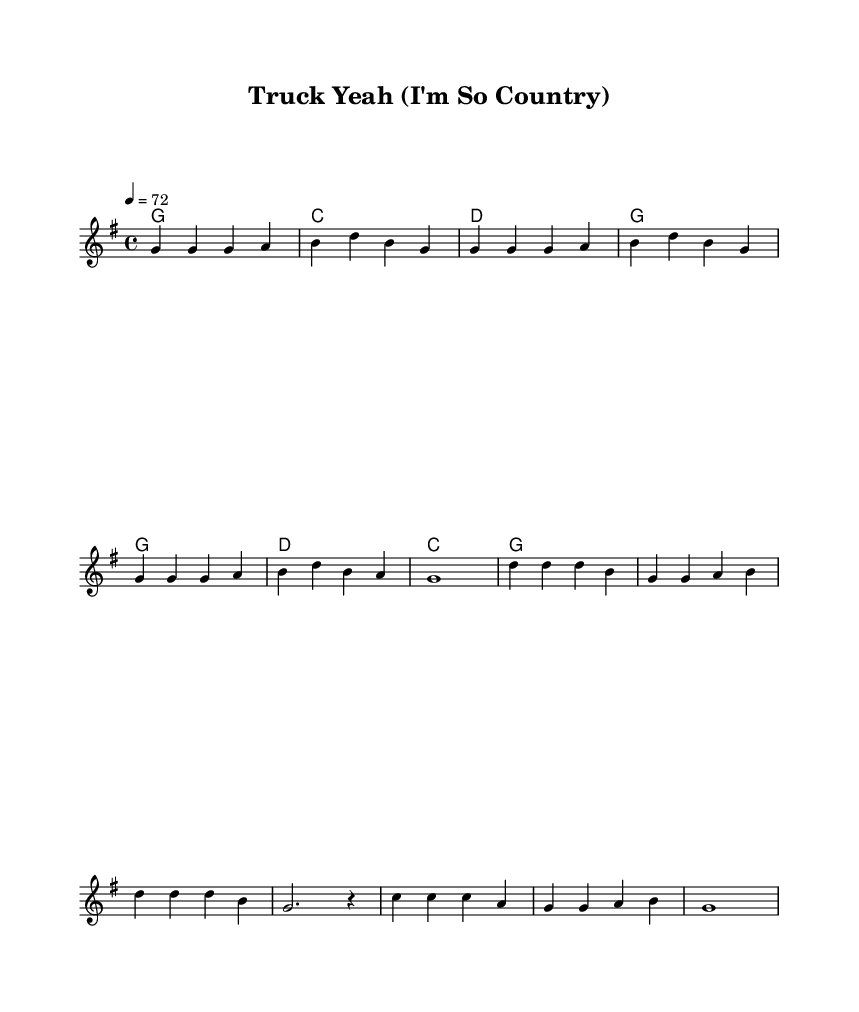What is the key signature of this music? The key signature is indicated at the beginning of the score and shows one sharp, which corresponds to G major.
Answer: G major What is the time signature of this music? The time signature is shown after the clef at the beginning of the score and it indicates four beats per measure, specifically 4/4.
Answer: 4/4 What is the tempo marking of this music? The tempo is given in the score and is indicated by the number that signifies beats per minute, which is set to 72.
Answer: 72 How many measures are in the verse section? By counting the individual measures represented in the melody section before the chorus starts, there are a total of 6 measures in the verse.
Answer: 6 What chords are used in the chorus section? The chorus section employs the chords indicated in the harmonies, which are G, D, C, and G again for the last measure.
Answer: G, D, C What is the primary theme of the lyrics in this piece? The lyrics depict a humorous portrayal of country music stereotypes, focusing on elements associated with being "country" such as trucks and farming, reflecting a satirical take.
Answer: Satirical portrayal of country stereotypes What kind of humor is illustrated in the lyrics? The humor is derived from exaggeration and irony in portraying traditional country lifestyle elements, specifically by highlighting how they align with modern country music stereotypes.
Answer: Exaggeration and irony 